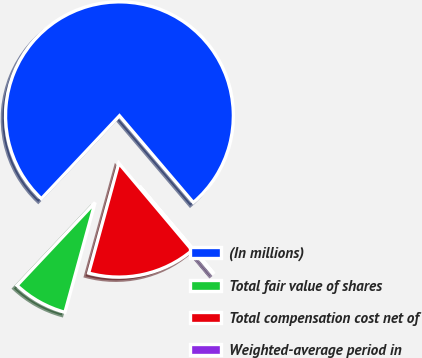Convert chart. <chart><loc_0><loc_0><loc_500><loc_500><pie_chart><fcel>(In millions)<fcel>Total fair value of shares<fcel>Total compensation cost net of<fcel>Weighted-average period in<nl><fcel>76.76%<fcel>7.75%<fcel>15.41%<fcel>0.08%<nl></chart> 